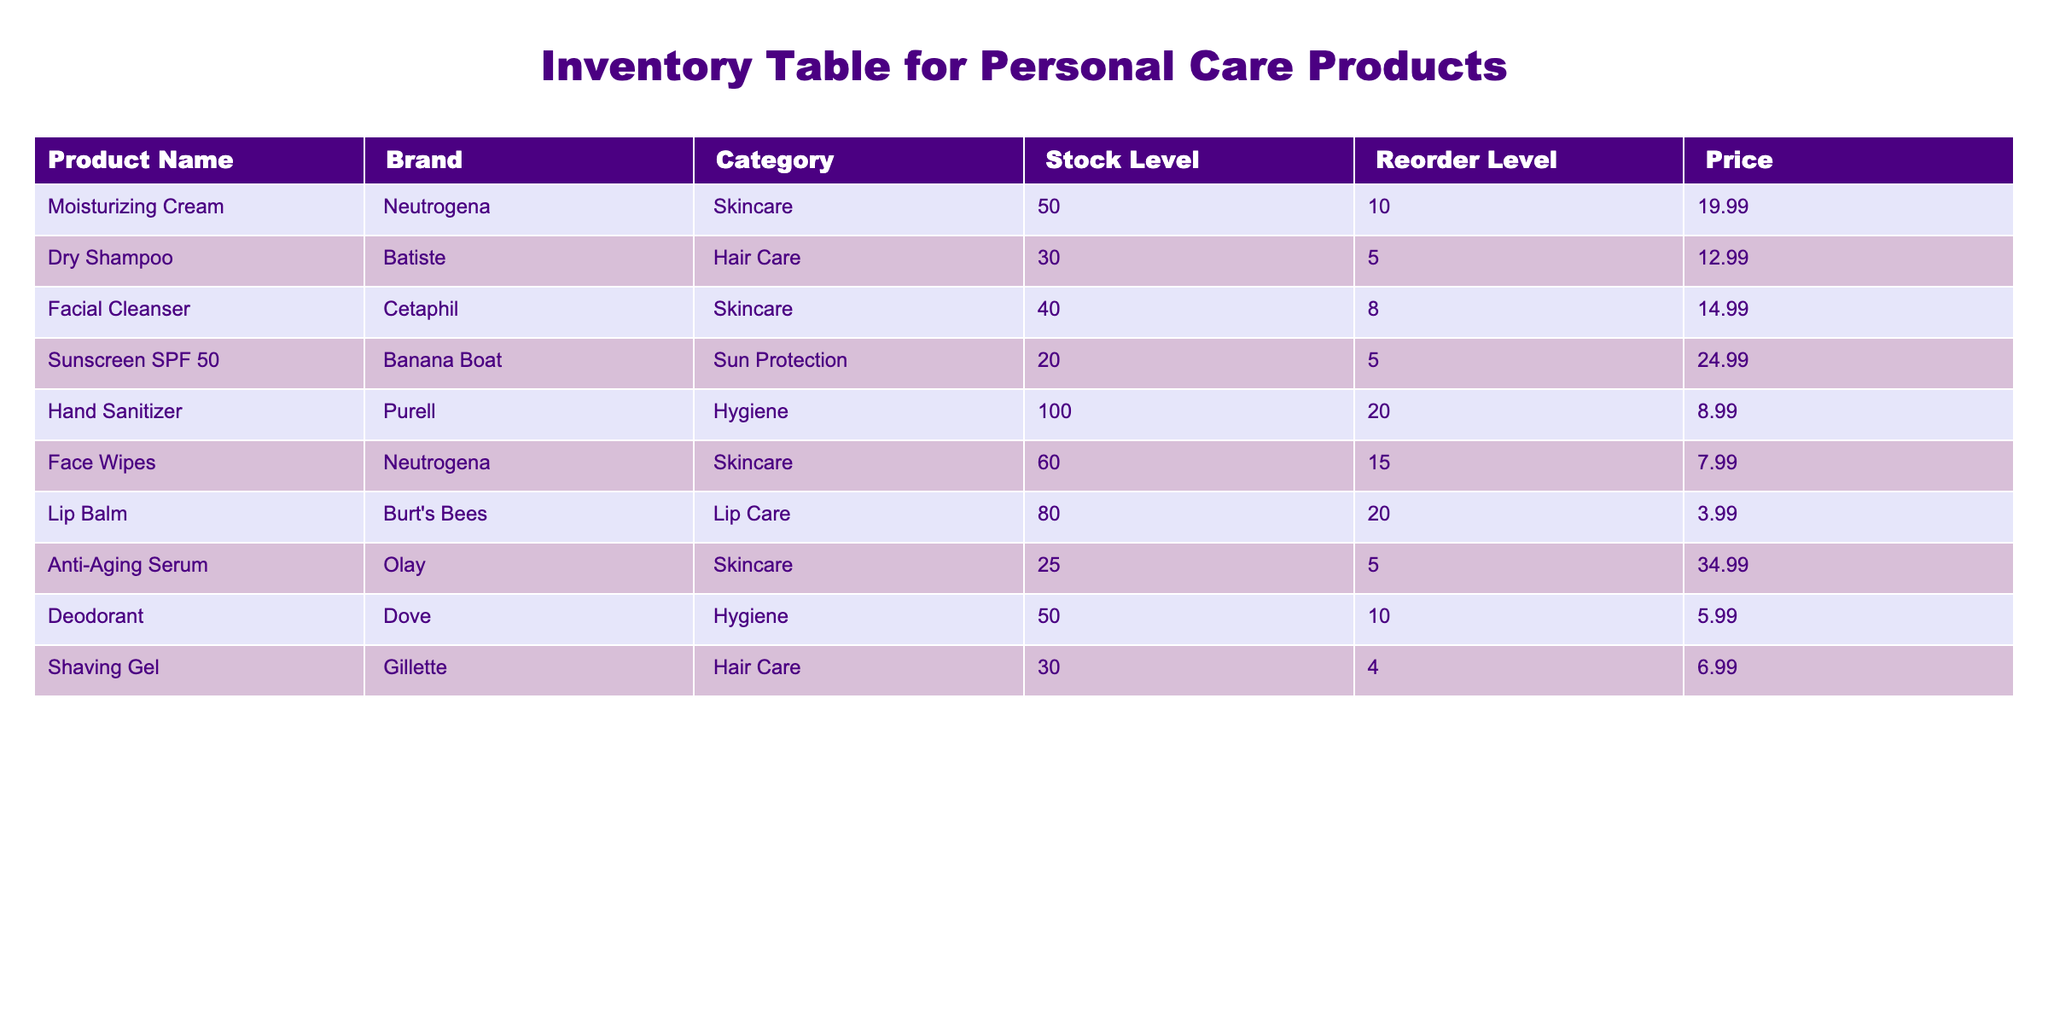What is the stock level of the Dry Shampoo? The stock level of the Dry Shampoo is directly listed under the "Stock Level" column for that product. Referring to the table, it shows a stock level of 30.
Answer: 30 Which product has the highest stock level? By comparing all the stock levels for each product, the highest stock level is found in the Hand Sanitizer, with 100 in stock.
Answer: Hand Sanitizer Is the Anti-Aging Serum below its reorder level? The Anti-Aging Serum shows a stock level of 25 and a reorder level of 5. Since 25 is above 5, it is not below the reorder level.
Answer: No What is the average price of all Hair Care products? The Hair Care products listed are Dry Shampoo and Shaving Gel, with prices of 12.99 and 6.99 respectively. Their average price is calculated as (12.99 + 6.99) / 2 = 9.99.
Answer: 9.99 How many skincare products are currently above their reorder level? The skincare products listed are Moisturizing Cream, Facial Cleanser, Face Wipes, and Anti-Aging Serum. Their stock levels are 50, 40, 60, and 25 respectively, and reorder levels are 10, 8, 15, and 5. All four products have stock levels above their reorder levels. Therefore, there are 4 products above their reorder level.
Answer: 4 What is the price difference between the most expensive and least expensive product? The most expensive product is the Anti-Aging Serum at 34.99, and the least expensive product is Lip Balm at 3.99. The difference is calculated as 34.99 - 3.99 = 31.00.
Answer: 31.00 Does the brand Burt's Bees offer any product at a stock level of 70 or above? The Lip Balm from Burt's Bees has a stock level of 80. Since 80 is greater than 70, the answer is yes.
Answer: Yes Which category has the minimum stock level? By reviewing the stock levels in each category, the category with the minimum stock level can be determined. The Sun Protection category has the least stock with only 20.
Answer: Sun Protection What is the total stock level of Hygiene products? The Hygiene products are Hand Sanitizer with 100 and Deodorant with 50. Adding these gives a total stock level of 100 + 50 = 150.
Answer: 150 